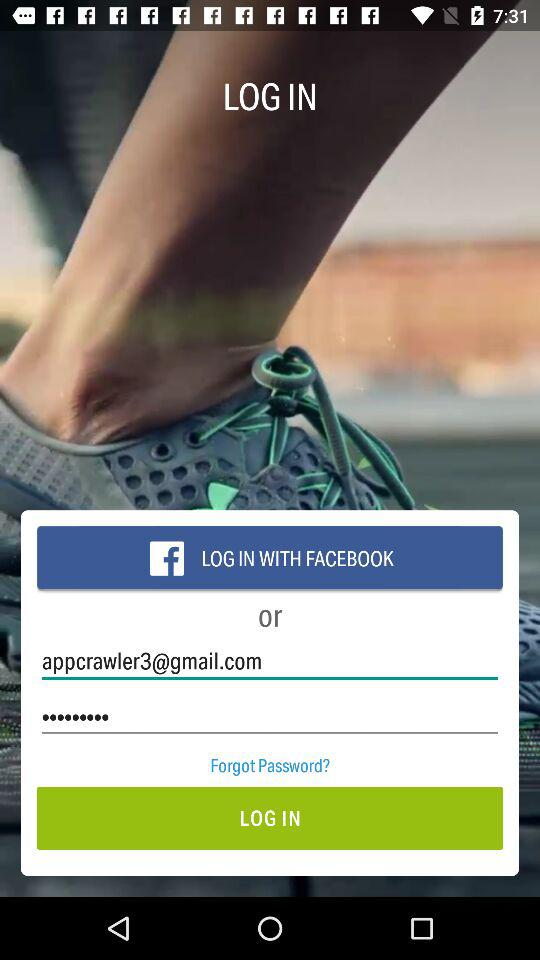What application can we use to log in? You can use "FACEBOOK" to log in. 